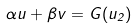<formula> <loc_0><loc_0><loc_500><loc_500>\alpha u + \beta v = G ( u _ { 2 } )</formula> 